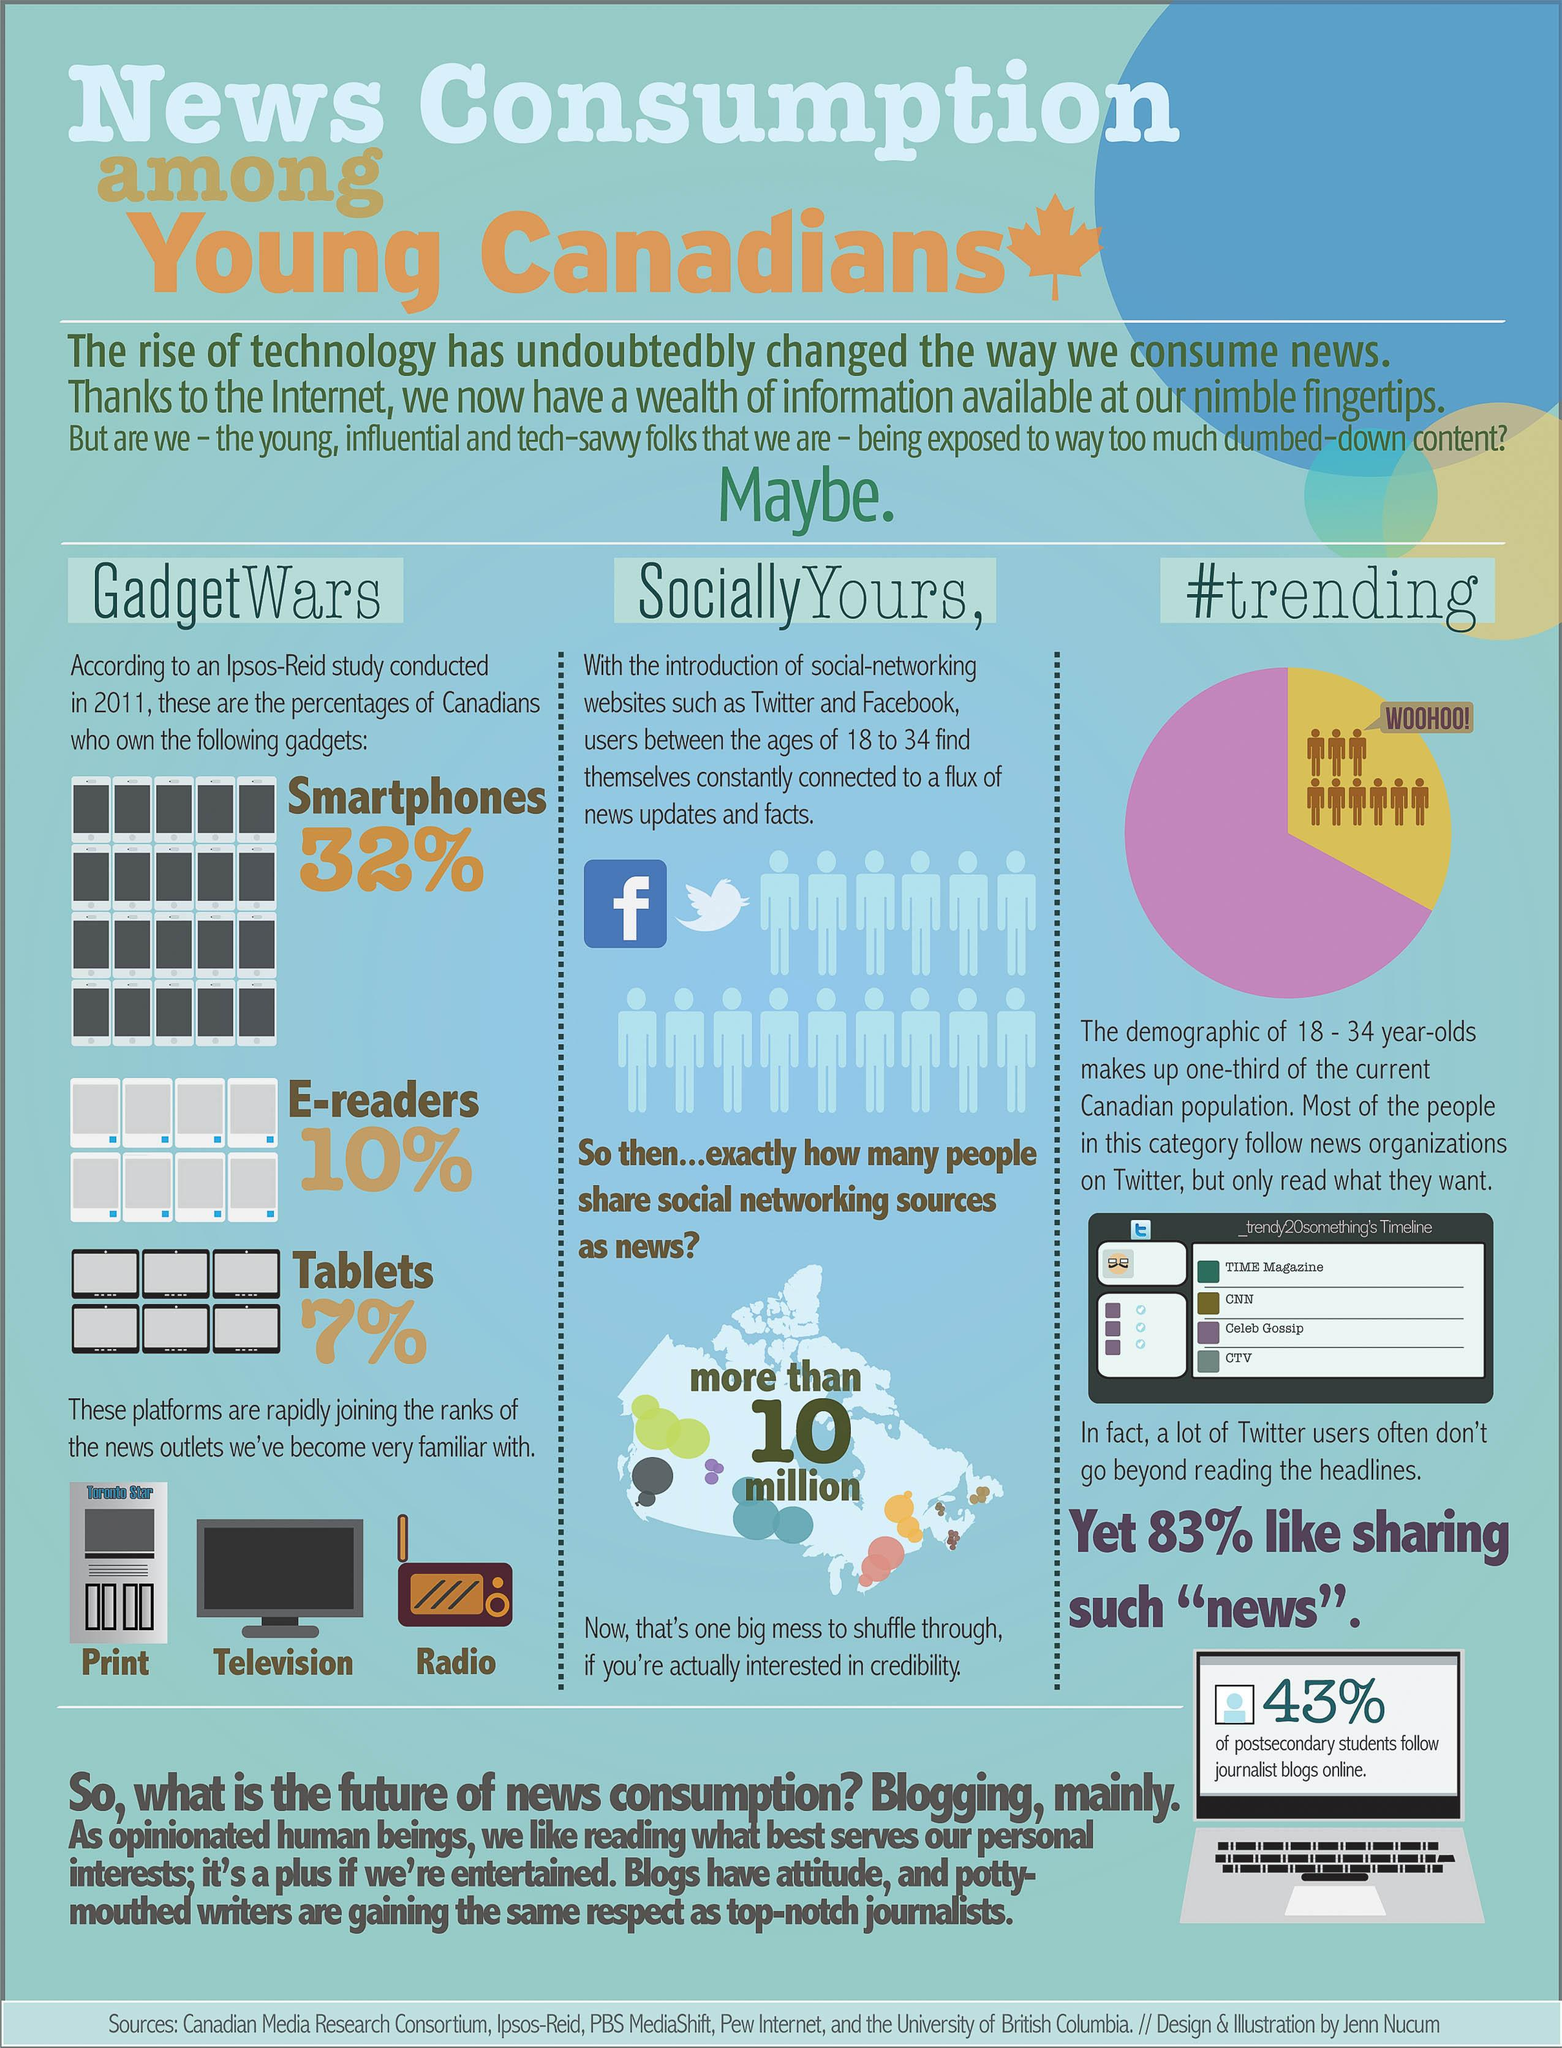Specify some key components in this picture. According to recent statistics, approximately 10% of Canadians own e-readers. It is estimated that more than 10 million people share social networking sources as a source of news. It is known that 32% of Canadians own smartphones. We have become highly familiar with several news outlets, including print, television, and radio. The yellow section of the pie chart contains a comment that reads 'woohoo!', 